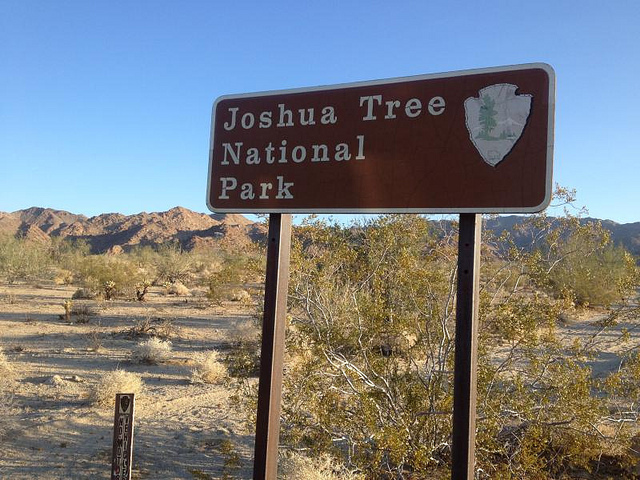Identify the text contained in this image. Joshua Tree Park National 